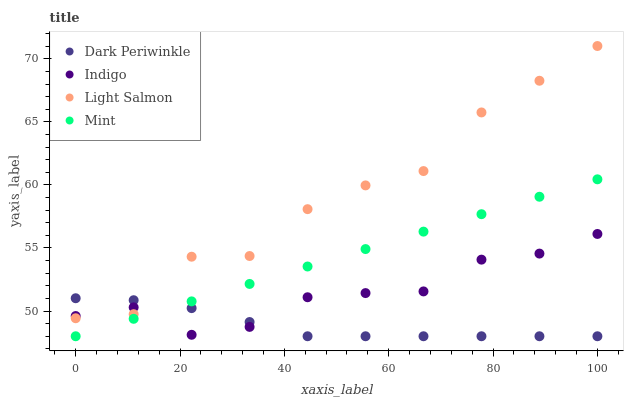Does Dark Periwinkle have the minimum area under the curve?
Answer yes or no. Yes. Does Light Salmon have the maximum area under the curve?
Answer yes or no. Yes. Does Indigo have the minimum area under the curve?
Answer yes or no. No. Does Indigo have the maximum area under the curve?
Answer yes or no. No. Is Mint the smoothest?
Answer yes or no. Yes. Is Light Salmon the roughest?
Answer yes or no. Yes. Is Indigo the smoothest?
Answer yes or no. No. Is Indigo the roughest?
Answer yes or no. No. Does Mint have the lowest value?
Answer yes or no. Yes. Does Indigo have the lowest value?
Answer yes or no. No. Does Light Salmon have the highest value?
Answer yes or no. Yes. Does Indigo have the highest value?
Answer yes or no. No. Is Mint less than Light Salmon?
Answer yes or no. Yes. Is Light Salmon greater than Mint?
Answer yes or no. Yes. Does Indigo intersect Mint?
Answer yes or no. Yes. Is Indigo less than Mint?
Answer yes or no. No. Is Indigo greater than Mint?
Answer yes or no. No. Does Mint intersect Light Salmon?
Answer yes or no. No. 